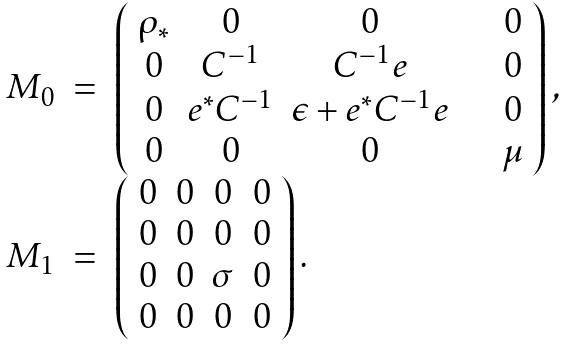Convert formula to latex. <formula><loc_0><loc_0><loc_500><loc_500>\begin{array} { r c l } M _ { 0 } & = & \left ( \begin{array} { c c c c } \rho _ { * } & 0 & 0 & \quad 0 \\ 0 & C ^ { - 1 } & C ^ { - 1 } e & \quad 0 \\ 0 & e ^ { * } C ^ { - 1 } & \epsilon + e ^ { * } C ^ { - 1 } e & \quad 0 \\ 0 & 0 & 0 & \quad \mu \end{array} \right ) , \\ M _ { 1 } & = & \left ( \begin{array} { c c c c } 0 & 0 & 0 & 0 \\ 0 & 0 & 0 & 0 \\ 0 & 0 & \sigma & 0 \\ 0 & 0 & 0 & 0 \end{array} \right ) . \end{array}</formula> 